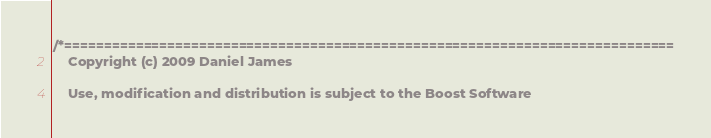<code> <loc_0><loc_0><loc_500><loc_500><_C++_>/*=============================================================================
    Copyright (c) 2009 Daniel James

    Use, modification and distribution is subject to the Boost Software</code> 